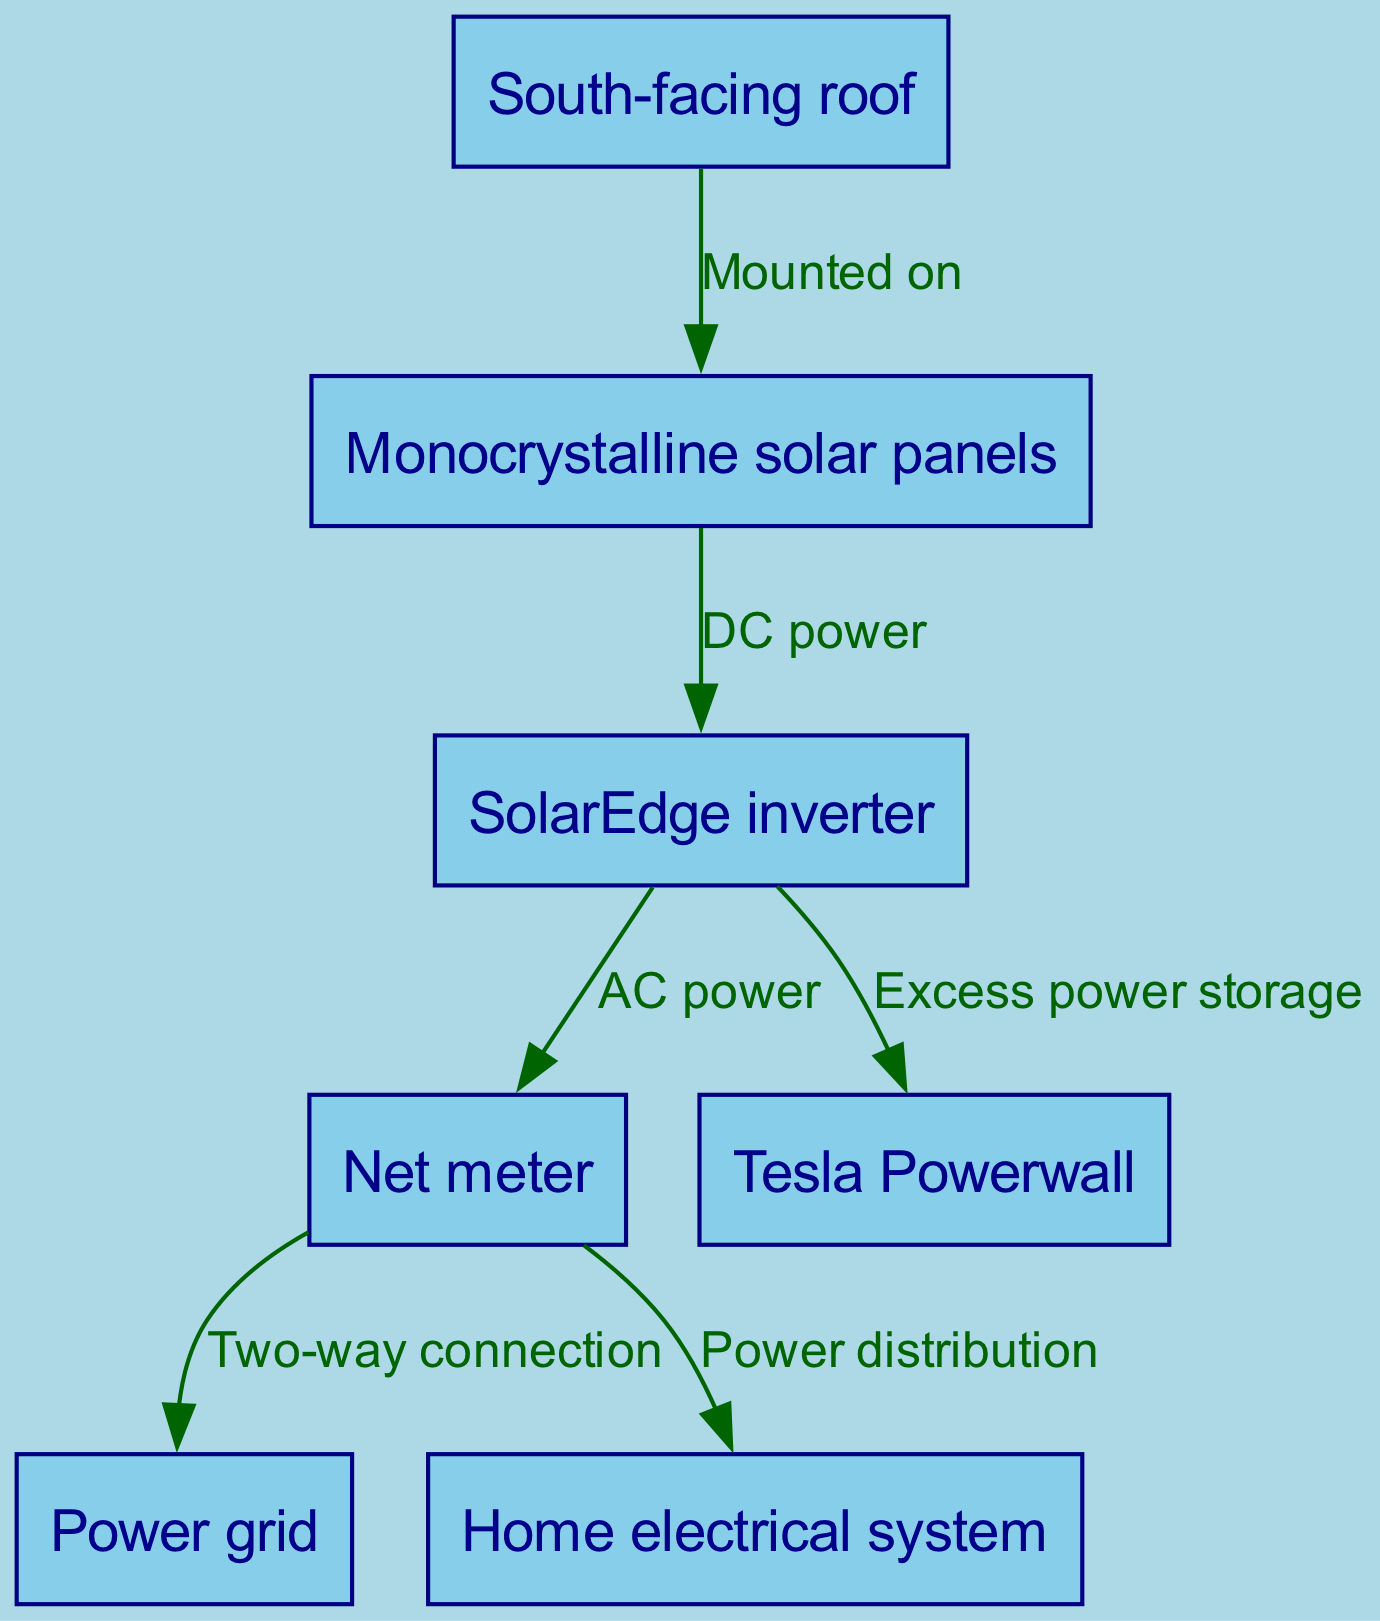What is the primary energy source for the system? The primary energy source in this solar panel installation is the solar panels mounted on the south-facing roof. They convert sunlight into direct current (DC) power.
Answer: Solar panels How many nodes are there in the diagram? The diagram includes six distinct nodes which represent different components of the solar panel installation system: the roof, solar panels, inverter, net meter, battery, and power grid, along with the home electrical system.
Answer: Six What is the function of the inverter in the system? The inverter is responsible for converting the DC power generated by the solar panels into alternating current (AC) power, which is then used by the home's electrical system and the net meter.
Answer: AC power Which component stores excess energy produced by the solar panels? The Tesla Powerwall is the component that stores excess energy produced by the solar panels. This energy can be used later when production is low or demand is high.
Answer: Tesla Powerwall What type of connection does the net meter have with the power grid? The net meter has a two-way connection with the power grid, allowing for both the export of excess energy back to the grid and the import of energy from it when needed.
Answer: Two-way connection How does power distribute to the home from the net meter? Power from the net meter is distributed directly to the home’s electrical system, ensuring that the home receives the necessary power for its operations.
Answer: Power distribution What type of solar panels are specified in the diagram? The diagram specifies monocrystalline solar panels as the type of solar panels used in the installation.
Answer: Monocrystalline solar panels What happens to the DC power generated by the solar panels? The DC power generated by the solar panels is routed to the inverter, where it is converted into AC power for use in the home and for distribution via the net meter.
Answer: AC power Which node is directly mounted on the roof? The solar panels are mounted directly on the south-facing roof, utilizing the available sunlight for energy generation.
Answer: Solar panels 